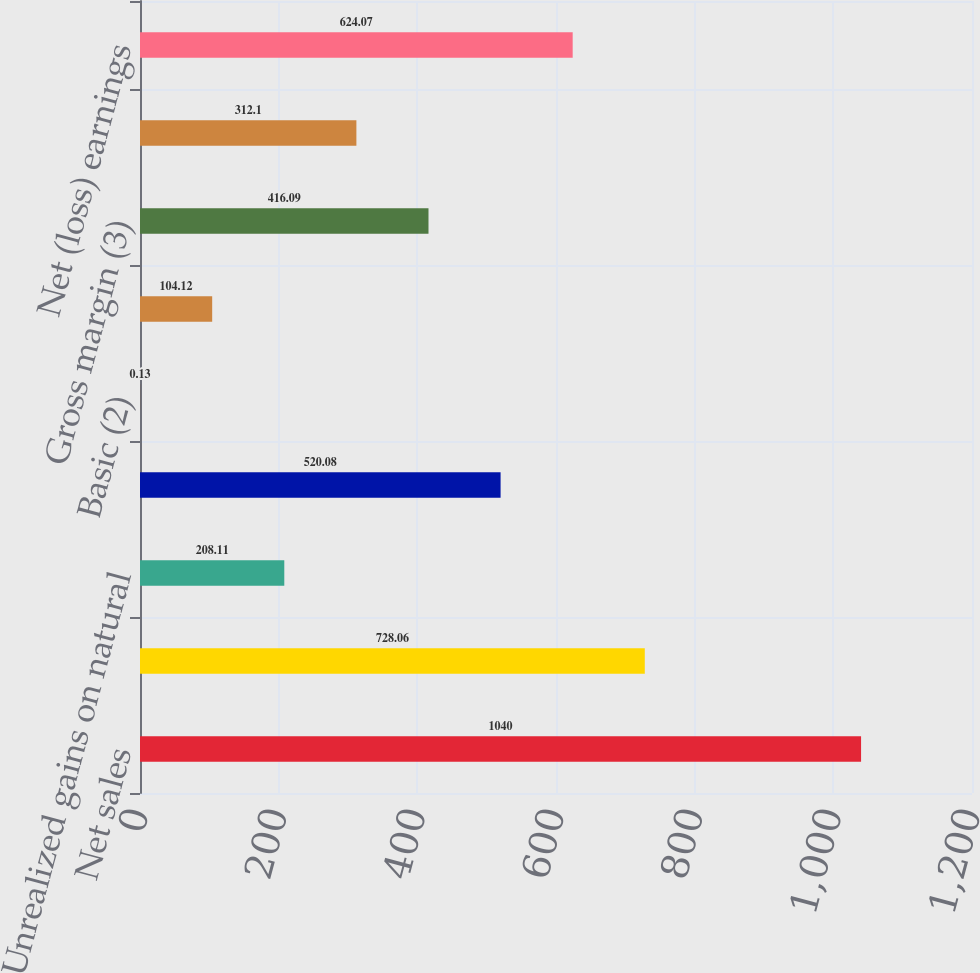Convert chart to OTSL. <chart><loc_0><loc_0><loc_500><loc_500><bar_chart><fcel>Net sales<fcel>Gross margin<fcel>Unrealized gains on natural<fcel>Net earnings attributable to<fcel>Basic (2)<fcel>Diluted (2)<fcel>Gross margin (3)<fcel>Unrealized (losses) gains on<fcel>Net (loss) earnings<nl><fcel>1040<fcel>728.06<fcel>208.11<fcel>520.08<fcel>0.13<fcel>104.12<fcel>416.09<fcel>312.1<fcel>624.07<nl></chart> 